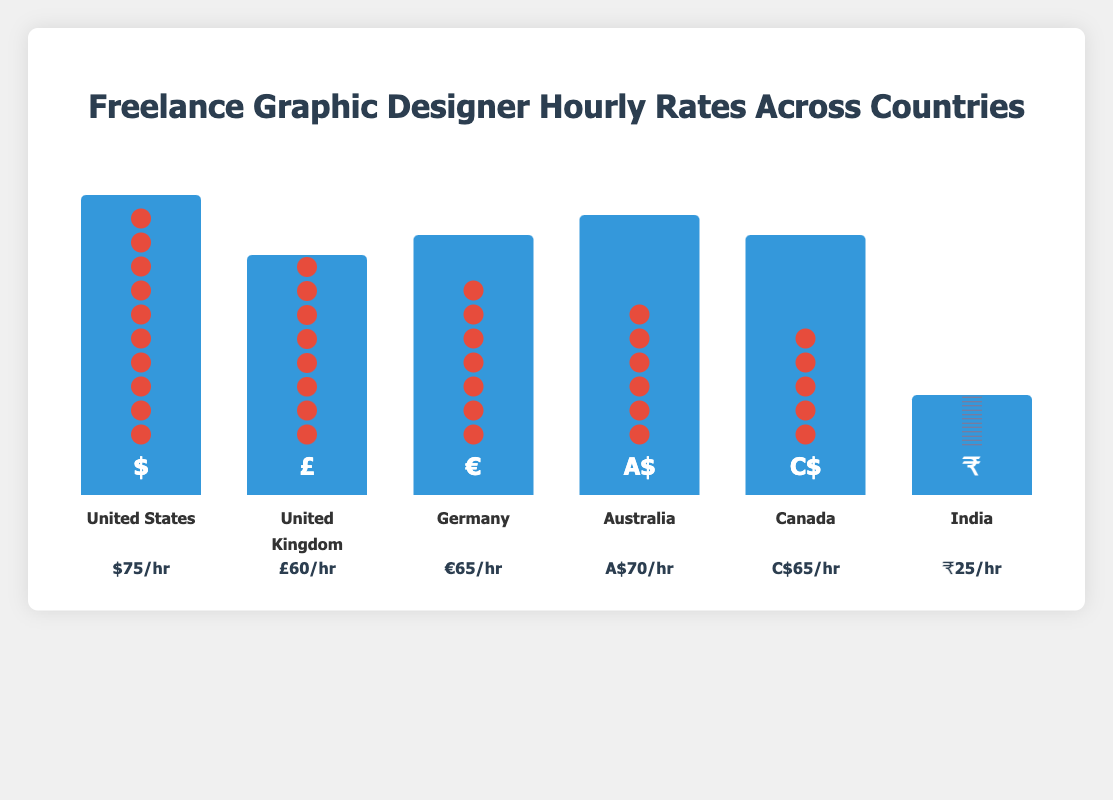How many freelance graphic designers are represented for India? The plot shows 12 designer icons for India, each representing one designer.
Answer: 12 What is the hourly rate for freelance graphic designers in Germany? The figure lists Germany's hourly rate as €65/hr underneath the bar.
Answer: €65/hr Which country has the highest hourly rate? Among the countries listed, the United States has the highest hourly rate at $75/hr, as indicated below the bar.
Answer: United States How does the hourly rate in Canada compare to Australia? Canada's hourly rate is C$65/hr and Australia's is A$70/hr, making Australia's rate $5 higher.
Answer: Australia has a $5 higher rate How many more freelance graphic designers are there in India compared to Australia? India has 12 designers, while Australia has 6. The difference is 12 - 6 = 6 designers.
Answer: 6 more designers What is the average hourly rate across all the countries listed? To find the average, sum the hourly rates and divide by the number of countries: (75 + 60 + 65 + 70 + 65 + 25)/6 = 60.
Answer: 60/hr Which country has the least number of freelance graphic designers represented? Canada has the least number of designers represented with 5, as shown by the icons.
Answer: Canada Between United Kingdom and Germany, which country has a higher hourly rate and by how much? The hourly rate in Germany is €65/hr and in the United Kingdom it is £60/hr. The difference is 65 - 60 = 5.
Answer: Germany by 5 What is the combined number of freelance graphic designers in the United States and the United Kingdom? United States has 10 designers and the United Kingdom has 8, so combined they have 10 + 8 = 18 designers.
Answer: 18 designers Compare the hourly rates of Australia and India. How many times higher is Australia's rate? Australia's hourly rate is A$70/hr and India's is ₹25/hr. The factor is 70/25 = 2.8.
Answer: 2.8 times higher 